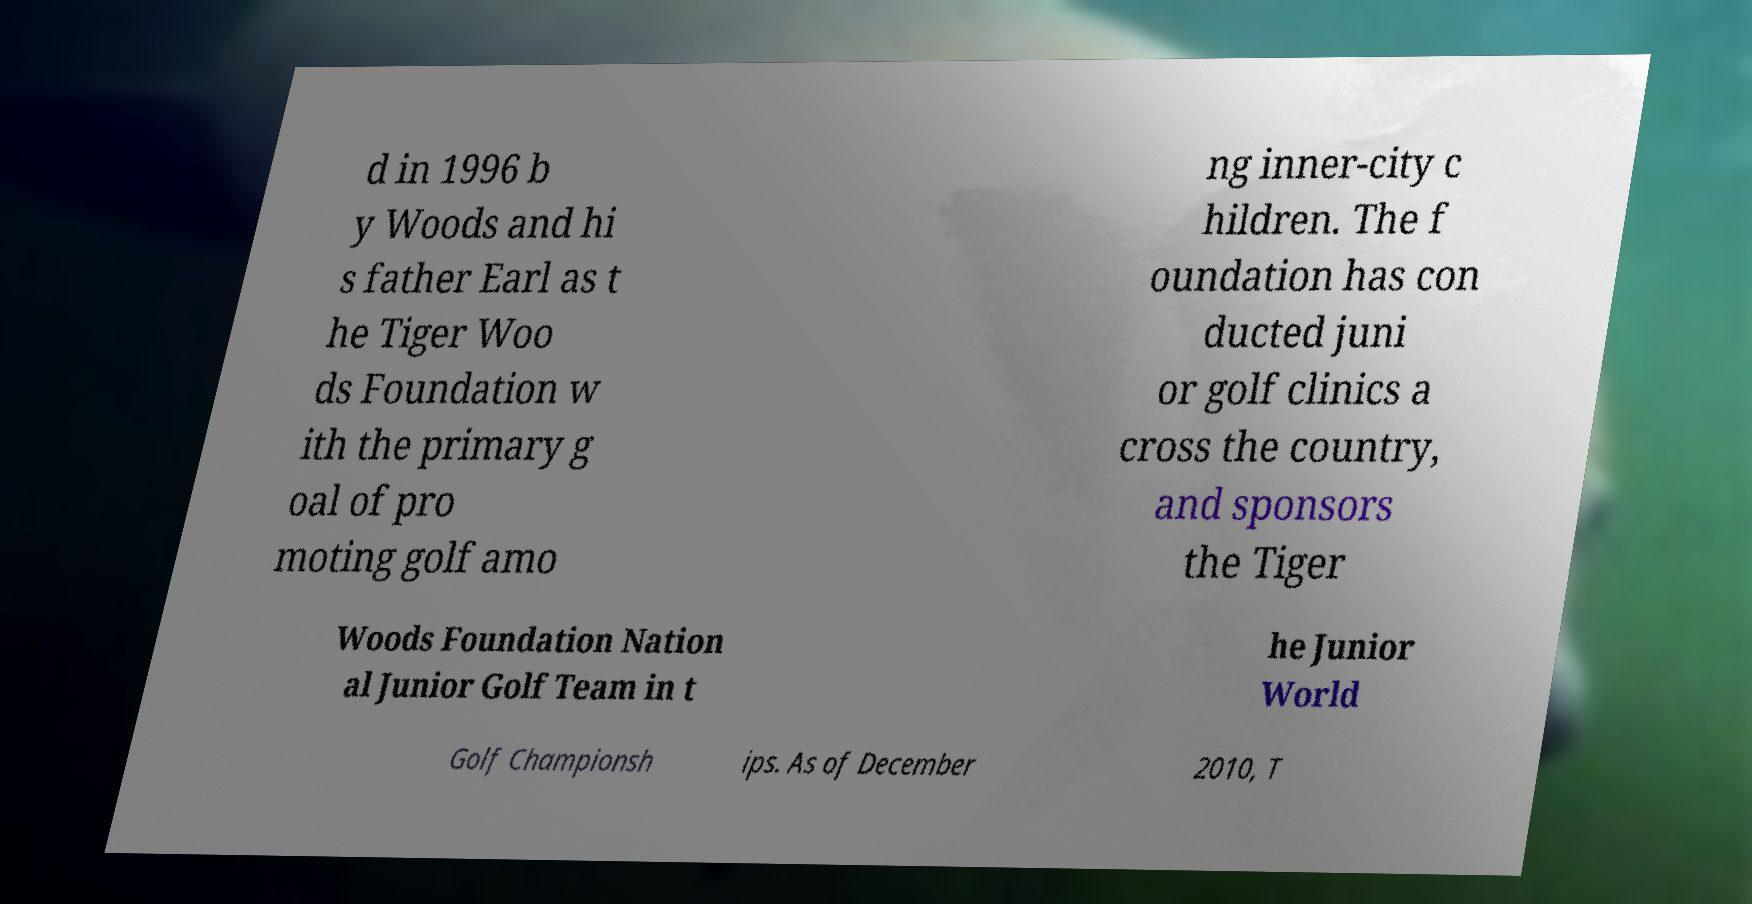Could you assist in decoding the text presented in this image and type it out clearly? d in 1996 b y Woods and hi s father Earl as t he Tiger Woo ds Foundation w ith the primary g oal of pro moting golf amo ng inner-city c hildren. The f oundation has con ducted juni or golf clinics a cross the country, and sponsors the Tiger Woods Foundation Nation al Junior Golf Team in t he Junior World Golf Championsh ips. As of December 2010, T 